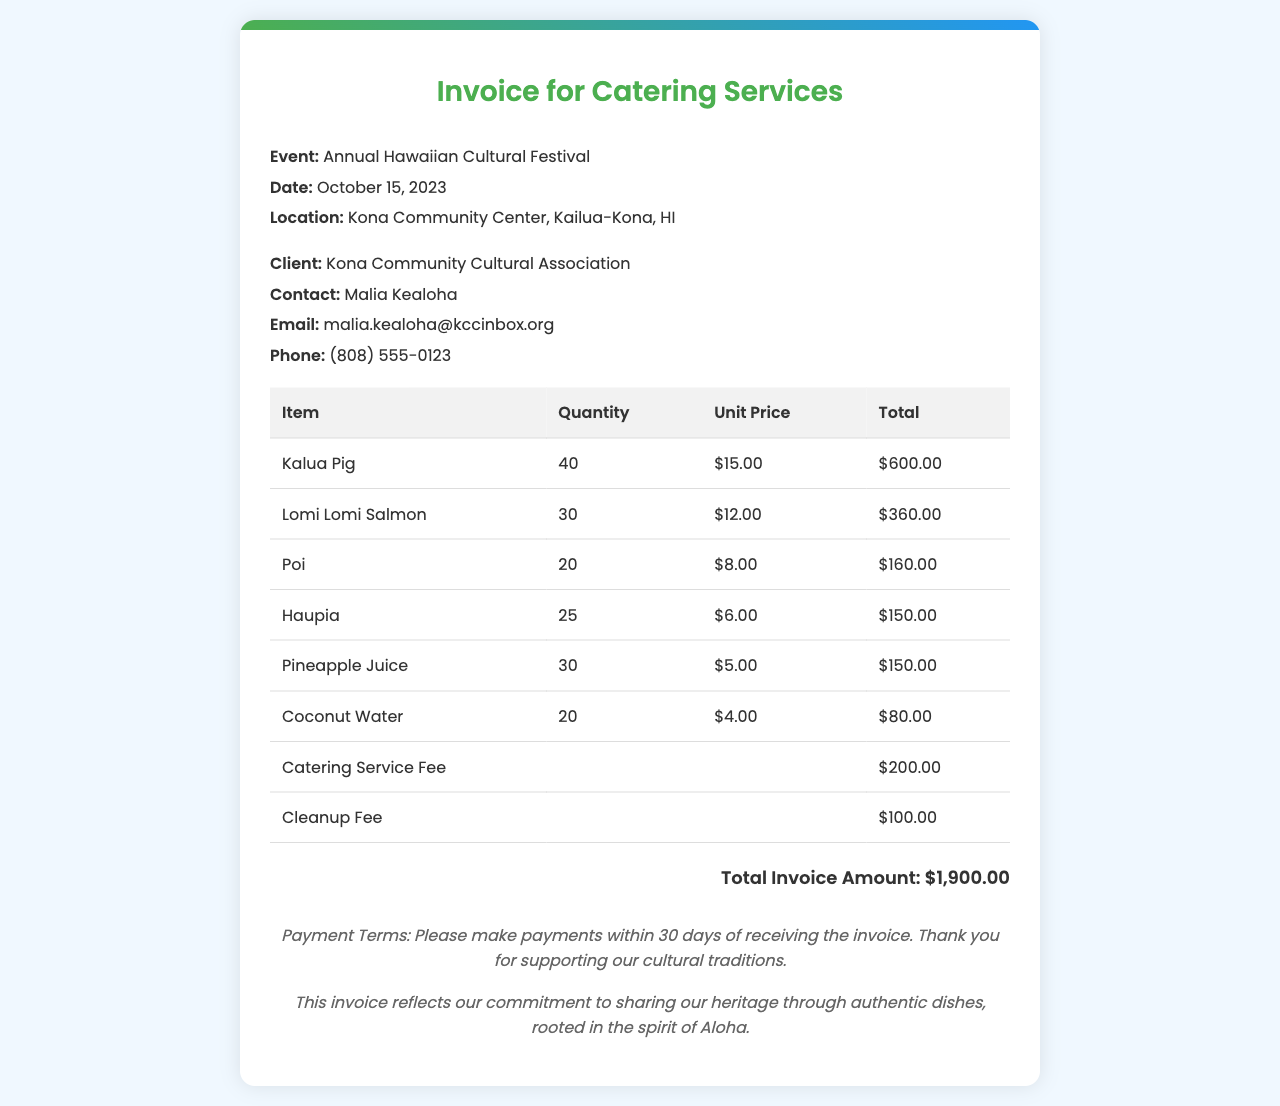What date is the event scheduled for? The invoice states the date of the event as October 15, 2023.
Answer: October 15, 2023 Who is the client for the catering services? In the document, the client is identified as Kona Community Cultural Association.
Answer: Kona Community Cultural Association What is the total amount for Kalua Pig? The total cost for Kalua Pig is calculated at the unit price multiplied by the quantity, which shows $600.00.
Answer: $600.00 What is included in the service fees? The document lists a Catering Service Fee and a Cleanup Fee as part of the service fees.
Answer: Catering Service Fee and Cleanup Fee How many servings of Lomi Lomi Salmon were ordered? The invoice specifies that 30 servings of Lomi Lomi Salmon were ordered.
Answer: 30 What is the total invoice amount? The invoice specifies the total invoice amount at the end, which is $1,900.00.
Answer: $1,900.00 What is the email contact for the client? The document provides the email contact as malia.kealoha@kccinbox.org.
Answer: malia.kealoha@kccinbox.org What is the location of the Annual Hawaiian Cultural Festival? The invoice lists the location as Kona Community Center, Kailua-Kona, HI.
Answer: Kona Community Center, Kailua-Kona, HI What type of cultural dish is Haupia? The document identifies Haupia as a dessert dish offered at the festival.
Answer: Dessert dish 